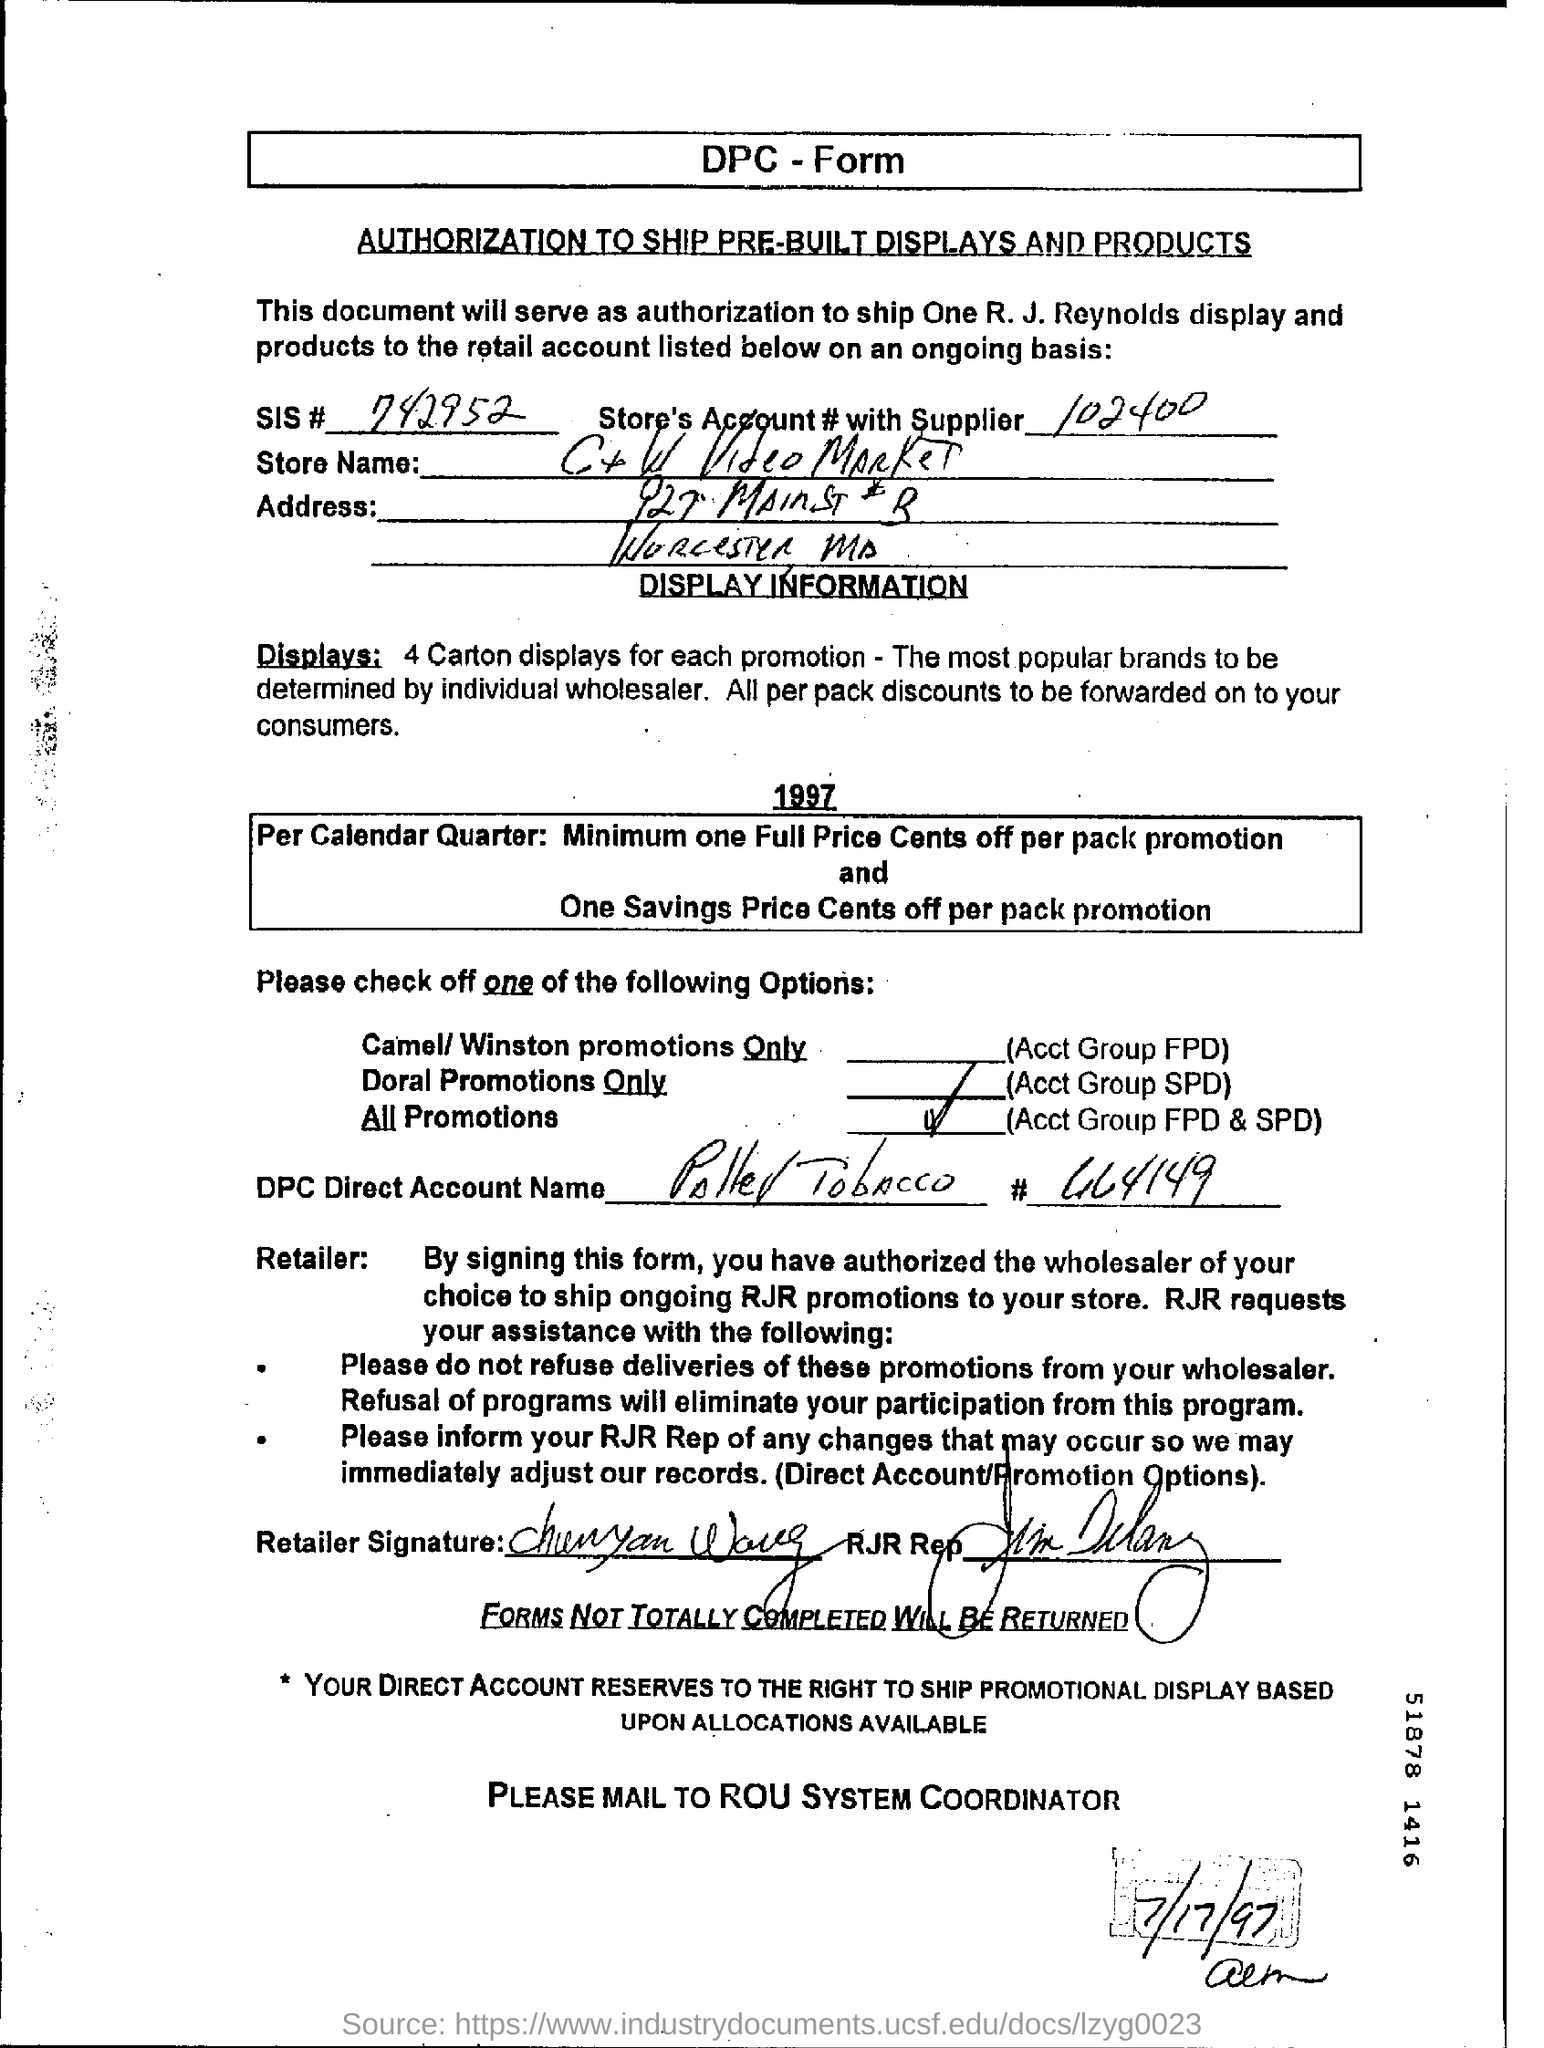Give some essential details in this illustration. The SIS number provided in the form is 742952... The date mentioned in this form is July 17, 1997. The account number provided in the form is 102400 